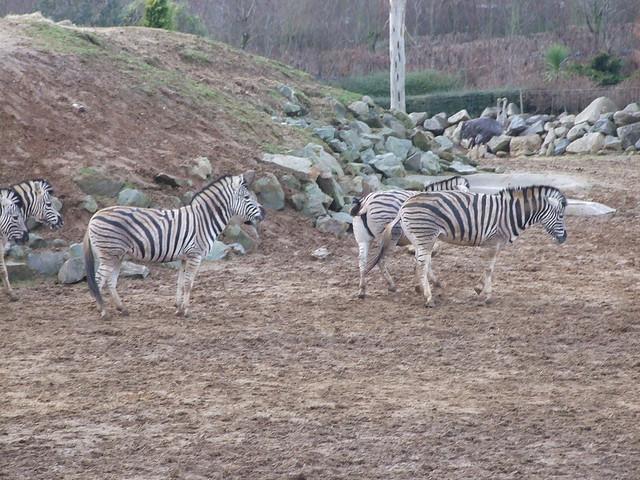How many zebras are there?
Answer briefly. 4. Where are the zebras?
Short answer required. Outside. Where are the large rocks?
Write a very short answer. In background. 